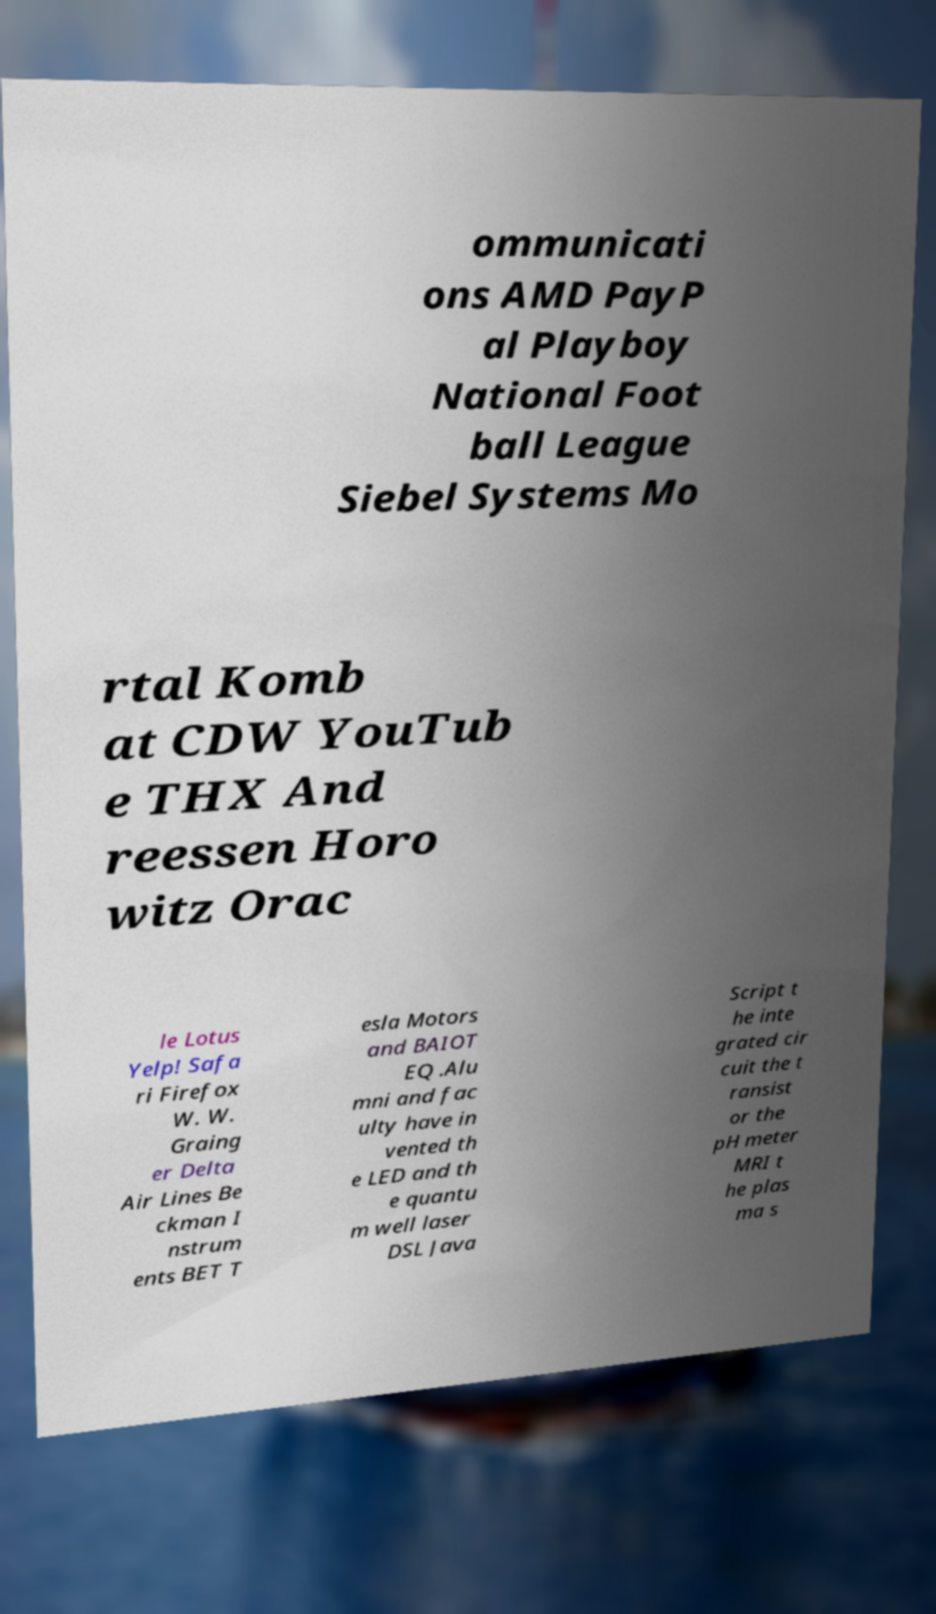Please identify and transcribe the text found in this image. ommunicati ons AMD PayP al Playboy National Foot ball League Siebel Systems Mo rtal Komb at CDW YouTub e THX And reessen Horo witz Orac le Lotus Yelp! Safa ri Firefox W. W. Graing er Delta Air Lines Be ckman I nstrum ents BET T esla Motors and BAIOT EQ .Alu mni and fac ulty have in vented th e LED and th e quantu m well laser DSL Java Script t he inte grated cir cuit the t ransist or the pH meter MRI t he plas ma s 